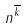Convert formula to latex. <formula><loc_0><loc_0><loc_500><loc_500>n ^ { \overline { k } }</formula> 